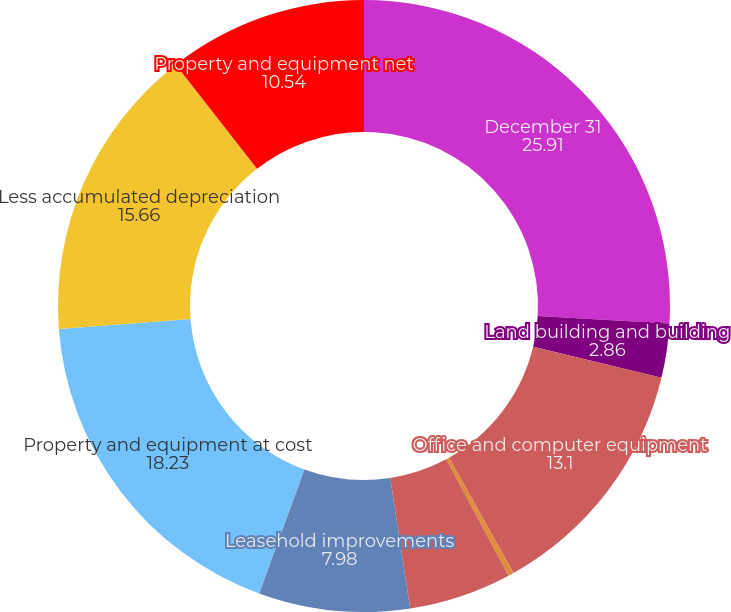Convert chart to OTSL. <chart><loc_0><loc_0><loc_500><loc_500><pie_chart><fcel>December 31<fcel>Land building and building<fcel>Office and computer equipment<fcel>Office furniture and fixtures<fcel>Internal-use computer software<fcel>Leasehold improvements<fcel>Property and equipment at cost<fcel>Less accumulated depreciation<fcel>Property and equipment net<nl><fcel>25.91%<fcel>2.86%<fcel>13.1%<fcel>0.3%<fcel>5.42%<fcel>7.98%<fcel>18.23%<fcel>15.66%<fcel>10.54%<nl></chart> 